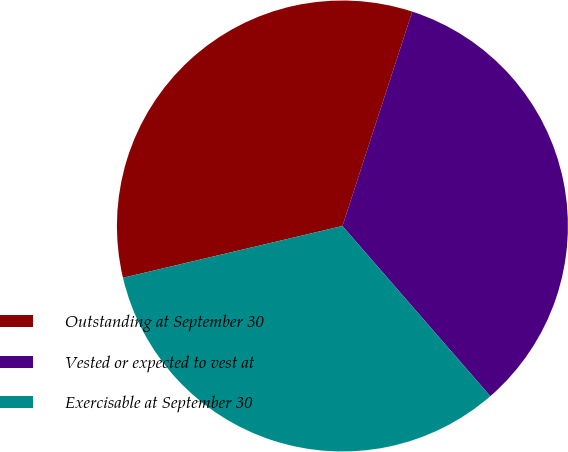Convert chart to OTSL. <chart><loc_0><loc_0><loc_500><loc_500><pie_chart><fcel>Outstanding at September 30<fcel>Vested or expected to vest at<fcel>Exercisable at September 30<nl><fcel>33.7%<fcel>33.6%<fcel>32.69%<nl></chart> 